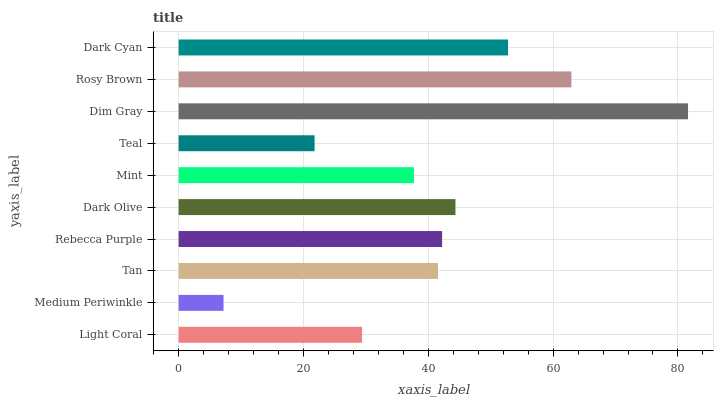Is Medium Periwinkle the minimum?
Answer yes or no. Yes. Is Dim Gray the maximum?
Answer yes or no. Yes. Is Tan the minimum?
Answer yes or no. No. Is Tan the maximum?
Answer yes or no. No. Is Tan greater than Medium Periwinkle?
Answer yes or no. Yes. Is Medium Periwinkle less than Tan?
Answer yes or no. Yes. Is Medium Periwinkle greater than Tan?
Answer yes or no. No. Is Tan less than Medium Periwinkle?
Answer yes or no. No. Is Rebecca Purple the high median?
Answer yes or no. Yes. Is Tan the low median?
Answer yes or no. Yes. Is Dark Olive the high median?
Answer yes or no. No. Is Dark Cyan the low median?
Answer yes or no. No. 